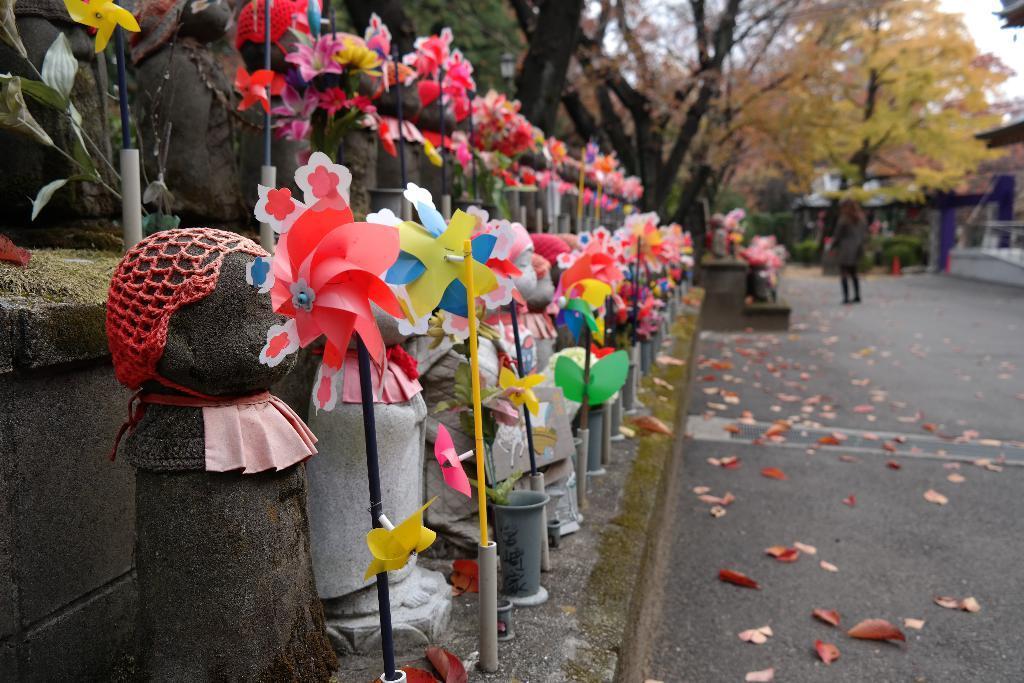Can you describe this image briefly? In this image we can see hand fans and there are trees. On the right there is a person standing. At the bottom we can see shredded leaves on the road. In the background there is sky. 